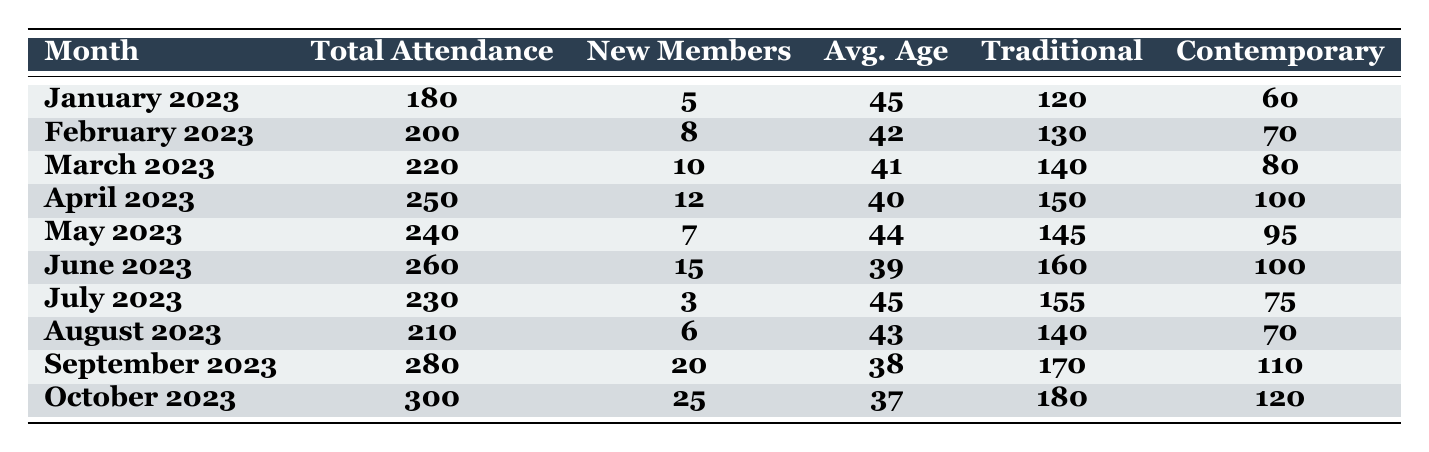What was the total attendance in October 2023? The table shows that the total attendance for October 2023 is listed directly as 300.
Answer: 300 How many new members joined in June 2023? According to the table, the number of new members for June 2023 is recorded as 15.
Answer: 15 Which month had the highest average age of attendees? Reviewing the average age column, January 2023 has the highest average age of 45.
Answer: January 2023 What was the total attendance for the first half of the year (January to June 2023)? Summing the total attendance for each month from January to June gives: 180 + 200 + 220 + 250 + 240 + 260 = 1350.
Answer: 1350 Did the attendance increase or decrease from May to June 2023? The attendance in May 2023 was 240, and in June 2023 it increased to 260. Therefore, it increased.
Answer: Increased What was the average attendance for the months from July to October 2023? The total attendance for July to October is 230 + 210 + 280 + 300 = 1020. There are 4 months, so the average is 1020 divided by 4, which equals 255.
Answer: 255 What percentage of the total attendance in September 2023 were new members? In September 2023, there were 280 total attendees and 20 new members. The percentage of new members = (20/280) * 100 = 7.14%.
Answer: 7.14% In which month was the attendance the lowest and what was the number? Looking at the total attendance column, January 2023 had the lowest attendance at 180.
Answer: January 2023, 180 Which type of service had more attendees in August 2023, traditional or contemporary? In August 2023, traditional services had 140 attendees while contemporary services had 70. Traditional services had more attendees.
Answer: Traditional What was the increase in total attendance from March 2023 to April 2023? The total attendance increased from March (220) to April (250), so the difference is 250 - 220 = 30.
Answer: 30 